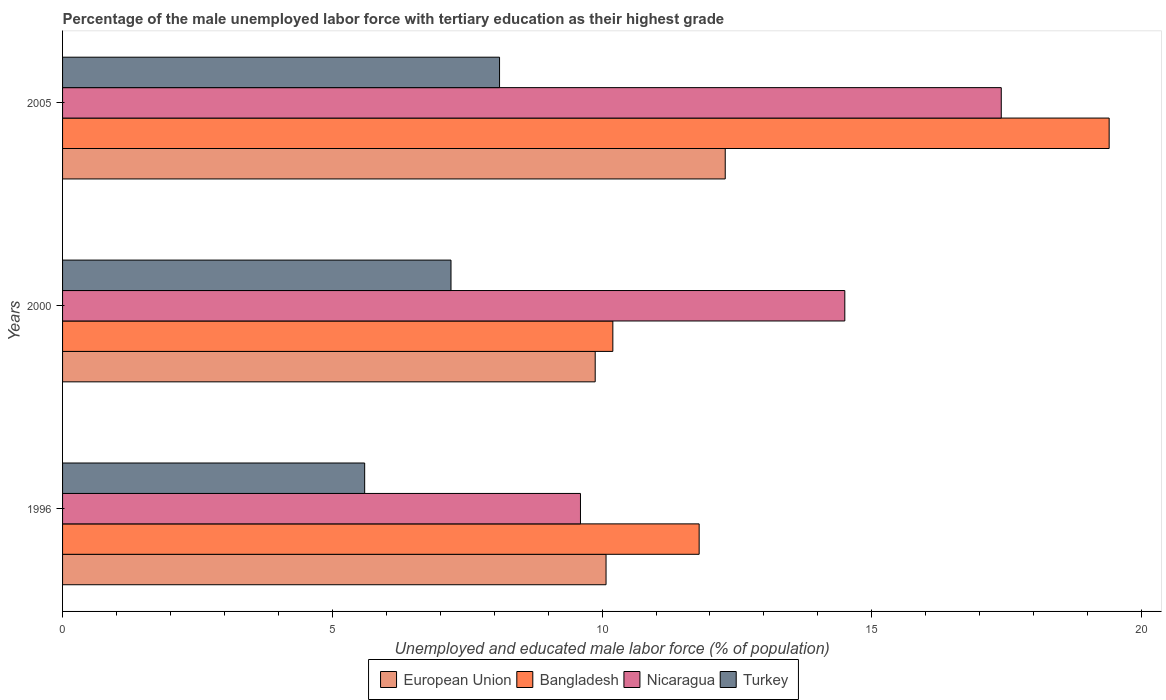How many different coloured bars are there?
Give a very brief answer. 4. How many bars are there on the 3rd tick from the bottom?
Offer a very short reply. 4. In how many cases, is the number of bars for a given year not equal to the number of legend labels?
Provide a short and direct response. 0. What is the percentage of the unemployed male labor force with tertiary education in Bangladesh in 2000?
Provide a short and direct response. 10.2. Across all years, what is the maximum percentage of the unemployed male labor force with tertiary education in Turkey?
Ensure brevity in your answer.  8.1. Across all years, what is the minimum percentage of the unemployed male labor force with tertiary education in European Union?
Your response must be concise. 9.87. What is the total percentage of the unemployed male labor force with tertiary education in Turkey in the graph?
Offer a terse response. 20.9. What is the difference between the percentage of the unemployed male labor force with tertiary education in Nicaragua in 2000 and that in 2005?
Ensure brevity in your answer.  -2.9. What is the difference between the percentage of the unemployed male labor force with tertiary education in European Union in 1996 and the percentage of the unemployed male labor force with tertiary education in Nicaragua in 2000?
Keep it short and to the point. -4.43. What is the average percentage of the unemployed male labor force with tertiary education in Nicaragua per year?
Give a very brief answer. 13.83. In the year 2000, what is the difference between the percentage of the unemployed male labor force with tertiary education in Nicaragua and percentage of the unemployed male labor force with tertiary education in Bangladesh?
Your answer should be compact. 4.3. In how many years, is the percentage of the unemployed male labor force with tertiary education in Turkey greater than 4 %?
Make the answer very short. 3. What is the ratio of the percentage of the unemployed male labor force with tertiary education in Nicaragua in 1996 to that in 2005?
Provide a succinct answer. 0.55. What is the difference between the highest and the second highest percentage of the unemployed male labor force with tertiary education in Bangladesh?
Your answer should be compact. 7.6. What is the difference between the highest and the lowest percentage of the unemployed male labor force with tertiary education in Bangladesh?
Provide a succinct answer. 9.2. Is the sum of the percentage of the unemployed male labor force with tertiary education in Turkey in 1996 and 2000 greater than the maximum percentage of the unemployed male labor force with tertiary education in European Union across all years?
Your answer should be compact. Yes. Is it the case that in every year, the sum of the percentage of the unemployed male labor force with tertiary education in Nicaragua and percentage of the unemployed male labor force with tertiary education in European Union is greater than the sum of percentage of the unemployed male labor force with tertiary education in Turkey and percentage of the unemployed male labor force with tertiary education in Bangladesh?
Give a very brief answer. No. What does the 3rd bar from the top in 2005 represents?
Provide a succinct answer. Bangladesh. Is it the case that in every year, the sum of the percentage of the unemployed male labor force with tertiary education in Nicaragua and percentage of the unemployed male labor force with tertiary education in European Union is greater than the percentage of the unemployed male labor force with tertiary education in Turkey?
Make the answer very short. Yes. How many bars are there?
Provide a short and direct response. 12. Are all the bars in the graph horizontal?
Keep it short and to the point. Yes. How many years are there in the graph?
Your response must be concise. 3. What is the difference between two consecutive major ticks on the X-axis?
Provide a short and direct response. 5. Are the values on the major ticks of X-axis written in scientific E-notation?
Offer a very short reply. No. Does the graph contain any zero values?
Provide a short and direct response. No. Where does the legend appear in the graph?
Your answer should be compact. Bottom center. How many legend labels are there?
Provide a short and direct response. 4. How are the legend labels stacked?
Provide a short and direct response. Horizontal. What is the title of the graph?
Your answer should be compact. Percentage of the male unemployed labor force with tertiary education as their highest grade. What is the label or title of the X-axis?
Your response must be concise. Unemployed and educated male labor force (% of population). What is the Unemployed and educated male labor force (% of population) of European Union in 1996?
Your answer should be compact. 10.07. What is the Unemployed and educated male labor force (% of population) of Bangladesh in 1996?
Make the answer very short. 11.8. What is the Unemployed and educated male labor force (% of population) in Nicaragua in 1996?
Keep it short and to the point. 9.6. What is the Unemployed and educated male labor force (% of population) of Turkey in 1996?
Offer a terse response. 5.6. What is the Unemployed and educated male labor force (% of population) of European Union in 2000?
Make the answer very short. 9.87. What is the Unemployed and educated male labor force (% of population) in Bangladesh in 2000?
Make the answer very short. 10.2. What is the Unemployed and educated male labor force (% of population) of Nicaragua in 2000?
Offer a terse response. 14.5. What is the Unemployed and educated male labor force (% of population) in Turkey in 2000?
Your response must be concise. 7.2. What is the Unemployed and educated male labor force (% of population) of European Union in 2005?
Keep it short and to the point. 12.28. What is the Unemployed and educated male labor force (% of population) in Bangladesh in 2005?
Give a very brief answer. 19.4. What is the Unemployed and educated male labor force (% of population) of Nicaragua in 2005?
Give a very brief answer. 17.4. What is the Unemployed and educated male labor force (% of population) in Turkey in 2005?
Ensure brevity in your answer.  8.1. Across all years, what is the maximum Unemployed and educated male labor force (% of population) in European Union?
Make the answer very short. 12.28. Across all years, what is the maximum Unemployed and educated male labor force (% of population) in Bangladesh?
Your answer should be very brief. 19.4. Across all years, what is the maximum Unemployed and educated male labor force (% of population) in Nicaragua?
Your response must be concise. 17.4. Across all years, what is the maximum Unemployed and educated male labor force (% of population) in Turkey?
Give a very brief answer. 8.1. Across all years, what is the minimum Unemployed and educated male labor force (% of population) in European Union?
Provide a succinct answer. 9.87. Across all years, what is the minimum Unemployed and educated male labor force (% of population) in Bangladesh?
Provide a succinct answer. 10.2. Across all years, what is the minimum Unemployed and educated male labor force (% of population) of Nicaragua?
Your response must be concise. 9.6. Across all years, what is the minimum Unemployed and educated male labor force (% of population) of Turkey?
Offer a terse response. 5.6. What is the total Unemployed and educated male labor force (% of population) in European Union in the graph?
Ensure brevity in your answer.  32.23. What is the total Unemployed and educated male labor force (% of population) of Bangladesh in the graph?
Make the answer very short. 41.4. What is the total Unemployed and educated male labor force (% of population) in Nicaragua in the graph?
Your answer should be compact. 41.5. What is the total Unemployed and educated male labor force (% of population) in Turkey in the graph?
Give a very brief answer. 20.9. What is the difference between the Unemployed and educated male labor force (% of population) in European Union in 1996 and that in 2000?
Your answer should be very brief. 0.2. What is the difference between the Unemployed and educated male labor force (% of population) in Nicaragua in 1996 and that in 2000?
Provide a short and direct response. -4.9. What is the difference between the Unemployed and educated male labor force (% of population) in Turkey in 1996 and that in 2000?
Offer a terse response. -1.6. What is the difference between the Unemployed and educated male labor force (% of population) of European Union in 1996 and that in 2005?
Offer a very short reply. -2.21. What is the difference between the Unemployed and educated male labor force (% of population) in Bangladesh in 1996 and that in 2005?
Your answer should be compact. -7.6. What is the difference between the Unemployed and educated male labor force (% of population) in Nicaragua in 1996 and that in 2005?
Offer a terse response. -7.8. What is the difference between the Unemployed and educated male labor force (% of population) in European Union in 2000 and that in 2005?
Offer a very short reply. -2.41. What is the difference between the Unemployed and educated male labor force (% of population) of European Union in 1996 and the Unemployed and educated male labor force (% of population) of Bangladesh in 2000?
Your answer should be compact. -0.13. What is the difference between the Unemployed and educated male labor force (% of population) in European Union in 1996 and the Unemployed and educated male labor force (% of population) in Nicaragua in 2000?
Your response must be concise. -4.43. What is the difference between the Unemployed and educated male labor force (% of population) of European Union in 1996 and the Unemployed and educated male labor force (% of population) of Turkey in 2000?
Make the answer very short. 2.87. What is the difference between the Unemployed and educated male labor force (% of population) of Bangladesh in 1996 and the Unemployed and educated male labor force (% of population) of Nicaragua in 2000?
Offer a terse response. -2.7. What is the difference between the Unemployed and educated male labor force (% of population) of Bangladesh in 1996 and the Unemployed and educated male labor force (% of population) of Turkey in 2000?
Your answer should be very brief. 4.6. What is the difference between the Unemployed and educated male labor force (% of population) in Nicaragua in 1996 and the Unemployed and educated male labor force (% of population) in Turkey in 2000?
Ensure brevity in your answer.  2.4. What is the difference between the Unemployed and educated male labor force (% of population) of European Union in 1996 and the Unemployed and educated male labor force (% of population) of Bangladesh in 2005?
Your response must be concise. -9.33. What is the difference between the Unemployed and educated male labor force (% of population) in European Union in 1996 and the Unemployed and educated male labor force (% of population) in Nicaragua in 2005?
Your response must be concise. -7.33. What is the difference between the Unemployed and educated male labor force (% of population) in European Union in 1996 and the Unemployed and educated male labor force (% of population) in Turkey in 2005?
Ensure brevity in your answer.  1.97. What is the difference between the Unemployed and educated male labor force (% of population) of Bangladesh in 1996 and the Unemployed and educated male labor force (% of population) of Nicaragua in 2005?
Make the answer very short. -5.6. What is the difference between the Unemployed and educated male labor force (% of population) of Nicaragua in 1996 and the Unemployed and educated male labor force (% of population) of Turkey in 2005?
Keep it short and to the point. 1.5. What is the difference between the Unemployed and educated male labor force (% of population) of European Union in 2000 and the Unemployed and educated male labor force (% of population) of Bangladesh in 2005?
Provide a succinct answer. -9.53. What is the difference between the Unemployed and educated male labor force (% of population) of European Union in 2000 and the Unemployed and educated male labor force (% of population) of Nicaragua in 2005?
Make the answer very short. -7.53. What is the difference between the Unemployed and educated male labor force (% of population) of European Union in 2000 and the Unemployed and educated male labor force (% of population) of Turkey in 2005?
Your answer should be very brief. 1.77. What is the average Unemployed and educated male labor force (% of population) of European Union per year?
Your response must be concise. 10.74. What is the average Unemployed and educated male labor force (% of population) in Nicaragua per year?
Keep it short and to the point. 13.83. What is the average Unemployed and educated male labor force (% of population) in Turkey per year?
Offer a very short reply. 6.97. In the year 1996, what is the difference between the Unemployed and educated male labor force (% of population) of European Union and Unemployed and educated male labor force (% of population) of Bangladesh?
Offer a very short reply. -1.73. In the year 1996, what is the difference between the Unemployed and educated male labor force (% of population) in European Union and Unemployed and educated male labor force (% of population) in Nicaragua?
Your response must be concise. 0.47. In the year 1996, what is the difference between the Unemployed and educated male labor force (% of population) of European Union and Unemployed and educated male labor force (% of population) of Turkey?
Ensure brevity in your answer.  4.47. In the year 1996, what is the difference between the Unemployed and educated male labor force (% of population) of Bangladesh and Unemployed and educated male labor force (% of population) of Nicaragua?
Offer a very short reply. 2.2. In the year 1996, what is the difference between the Unemployed and educated male labor force (% of population) in Nicaragua and Unemployed and educated male labor force (% of population) in Turkey?
Your response must be concise. 4. In the year 2000, what is the difference between the Unemployed and educated male labor force (% of population) of European Union and Unemployed and educated male labor force (% of population) of Bangladesh?
Your answer should be compact. -0.33. In the year 2000, what is the difference between the Unemployed and educated male labor force (% of population) of European Union and Unemployed and educated male labor force (% of population) of Nicaragua?
Your answer should be very brief. -4.63. In the year 2000, what is the difference between the Unemployed and educated male labor force (% of population) in European Union and Unemployed and educated male labor force (% of population) in Turkey?
Offer a terse response. 2.67. In the year 2000, what is the difference between the Unemployed and educated male labor force (% of population) in Bangladesh and Unemployed and educated male labor force (% of population) in Nicaragua?
Provide a short and direct response. -4.3. In the year 2000, what is the difference between the Unemployed and educated male labor force (% of population) in Nicaragua and Unemployed and educated male labor force (% of population) in Turkey?
Keep it short and to the point. 7.3. In the year 2005, what is the difference between the Unemployed and educated male labor force (% of population) in European Union and Unemployed and educated male labor force (% of population) in Bangladesh?
Your answer should be very brief. -7.12. In the year 2005, what is the difference between the Unemployed and educated male labor force (% of population) in European Union and Unemployed and educated male labor force (% of population) in Nicaragua?
Give a very brief answer. -5.12. In the year 2005, what is the difference between the Unemployed and educated male labor force (% of population) of European Union and Unemployed and educated male labor force (% of population) of Turkey?
Offer a very short reply. 4.18. In the year 2005, what is the difference between the Unemployed and educated male labor force (% of population) in Bangladesh and Unemployed and educated male labor force (% of population) in Nicaragua?
Ensure brevity in your answer.  2. In the year 2005, what is the difference between the Unemployed and educated male labor force (% of population) of Nicaragua and Unemployed and educated male labor force (% of population) of Turkey?
Provide a succinct answer. 9.3. What is the ratio of the Unemployed and educated male labor force (% of population) of European Union in 1996 to that in 2000?
Your answer should be compact. 1.02. What is the ratio of the Unemployed and educated male labor force (% of population) in Bangladesh in 1996 to that in 2000?
Offer a terse response. 1.16. What is the ratio of the Unemployed and educated male labor force (% of population) in Nicaragua in 1996 to that in 2000?
Offer a terse response. 0.66. What is the ratio of the Unemployed and educated male labor force (% of population) of Turkey in 1996 to that in 2000?
Offer a very short reply. 0.78. What is the ratio of the Unemployed and educated male labor force (% of population) in European Union in 1996 to that in 2005?
Ensure brevity in your answer.  0.82. What is the ratio of the Unemployed and educated male labor force (% of population) in Bangladesh in 1996 to that in 2005?
Ensure brevity in your answer.  0.61. What is the ratio of the Unemployed and educated male labor force (% of population) in Nicaragua in 1996 to that in 2005?
Provide a succinct answer. 0.55. What is the ratio of the Unemployed and educated male labor force (% of population) of Turkey in 1996 to that in 2005?
Provide a succinct answer. 0.69. What is the ratio of the Unemployed and educated male labor force (% of population) of European Union in 2000 to that in 2005?
Your answer should be very brief. 0.8. What is the ratio of the Unemployed and educated male labor force (% of population) in Bangladesh in 2000 to that in 2005?
Make the answer very short. 0.53. What is the ratio of the Unemployed and educated male labor force (% of population) of Nicaragua in 2000 to that in 2005?
Offer a terse response. 0.83. What is the difference between the highest and the second highest Unemployed and educated male labor force (% of population) of European Union?
Your response must be concise. 2.21. What is the difference between the highest and the lowest Unemployed and educated male labor force (% of population) of European Union?
Offer a very short reply. 2.41. 